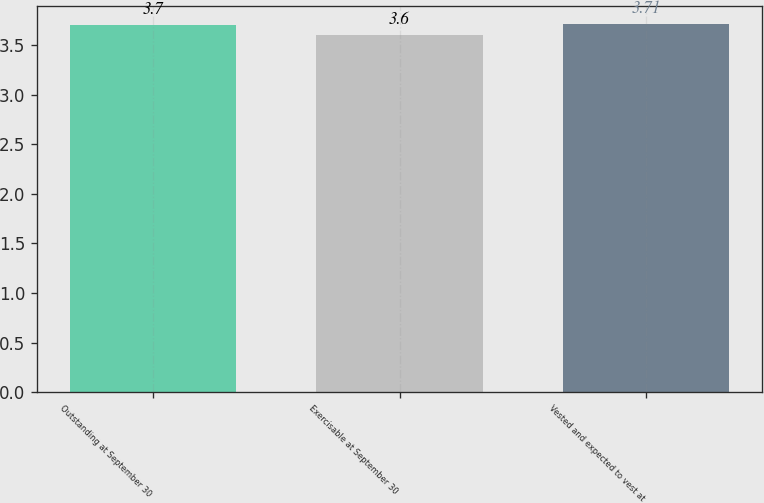<chart> <loc_0><loc_0><loc_500><loc_500><bar_chart><fcel>Outstanding at September 30<fcel>Exercisable at September 30<fcel>Vested and expected to vest at<nl><fcel>3.7<fcel>3.6<fcel>3.71<nl></chart> 